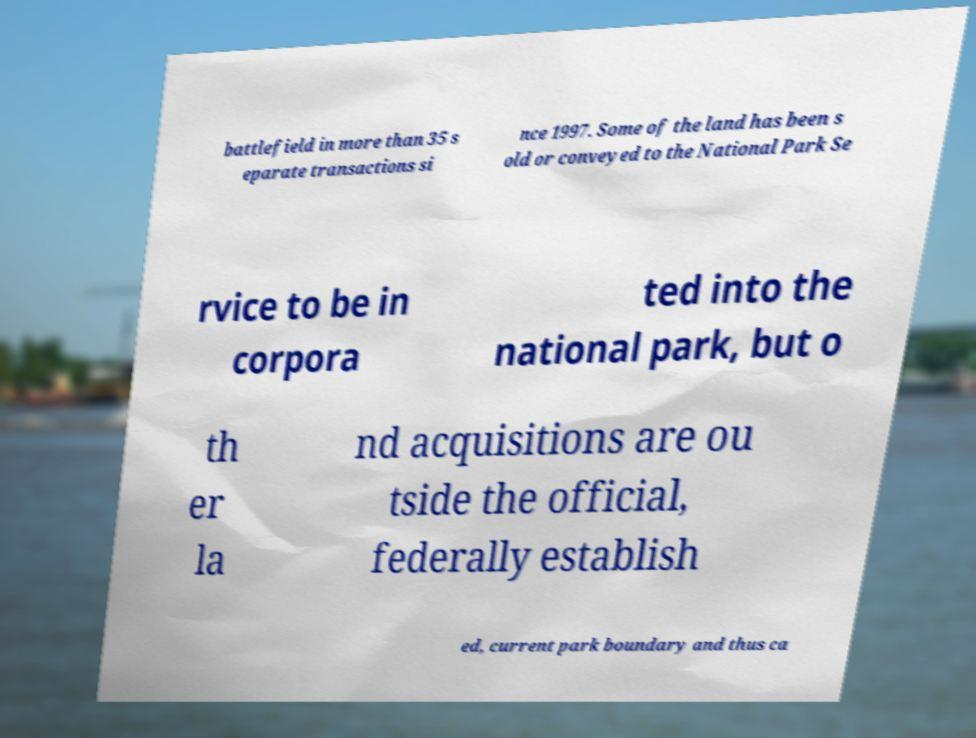Could you assist in decoding the text presented in this image and type it out clearly? battlefield in more than 35 s eparate transactions si nce 1997. Some of the land has been s old or conveyed to the National Park Se rvice to be in corpora ted into the national park, but o th er la nd acquisitions are ou tside the official, federally establish ed, current park boundary and thus ca 